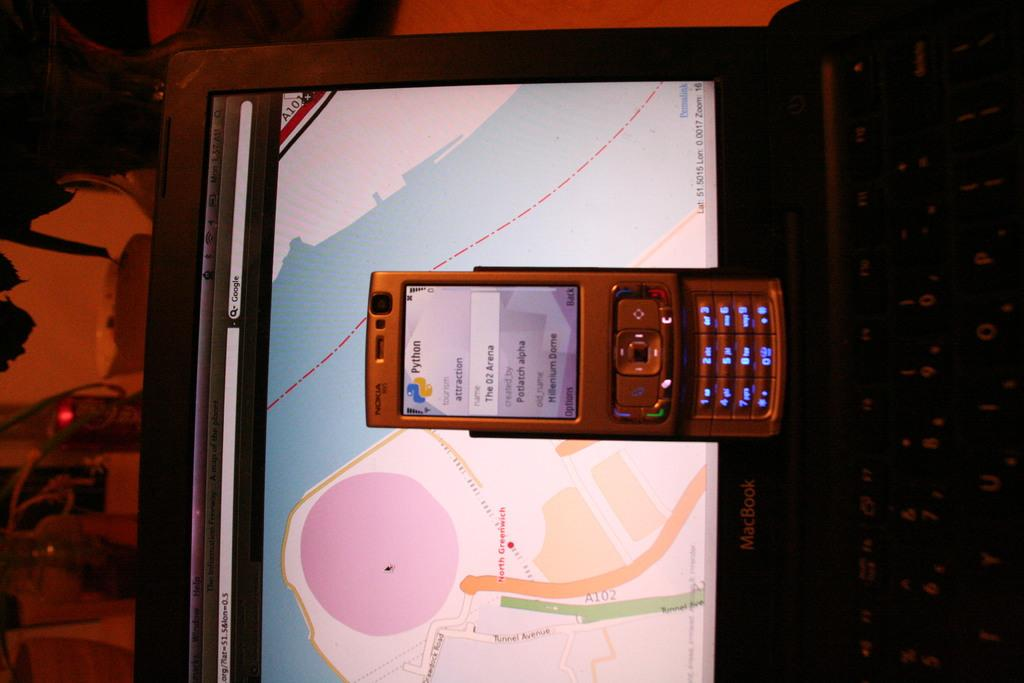<image>
Relay a brief, clear account of the picture shown. the word attraction is on the cell phone 